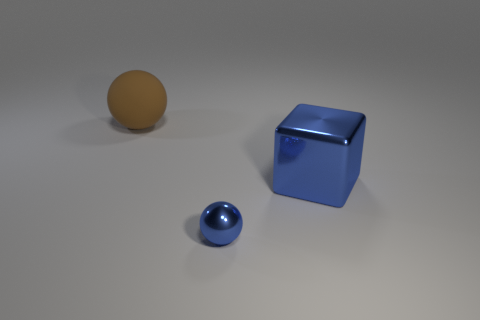Subtract all brown balls. How many balls are left? 1 Add 3 big brown things. How many objects exist? 6 Subtract all cubes. How many objects are left? 2 Subtract 1 blocks. How many blocks are left? 0 Subtract all blue objects. Subtract all red rubber objects. How many objects are left? 1 Add 2 small blue spheres. How many small blue spheres are left? 3 Add 3 big brown rubber balls. How many big brown rubber balls exist? 4 Subtract 0 green cylinders. How many objects are left? 3 Subtract all yellow balls. Subtract all blue cylinders. How many balls are left? 2 